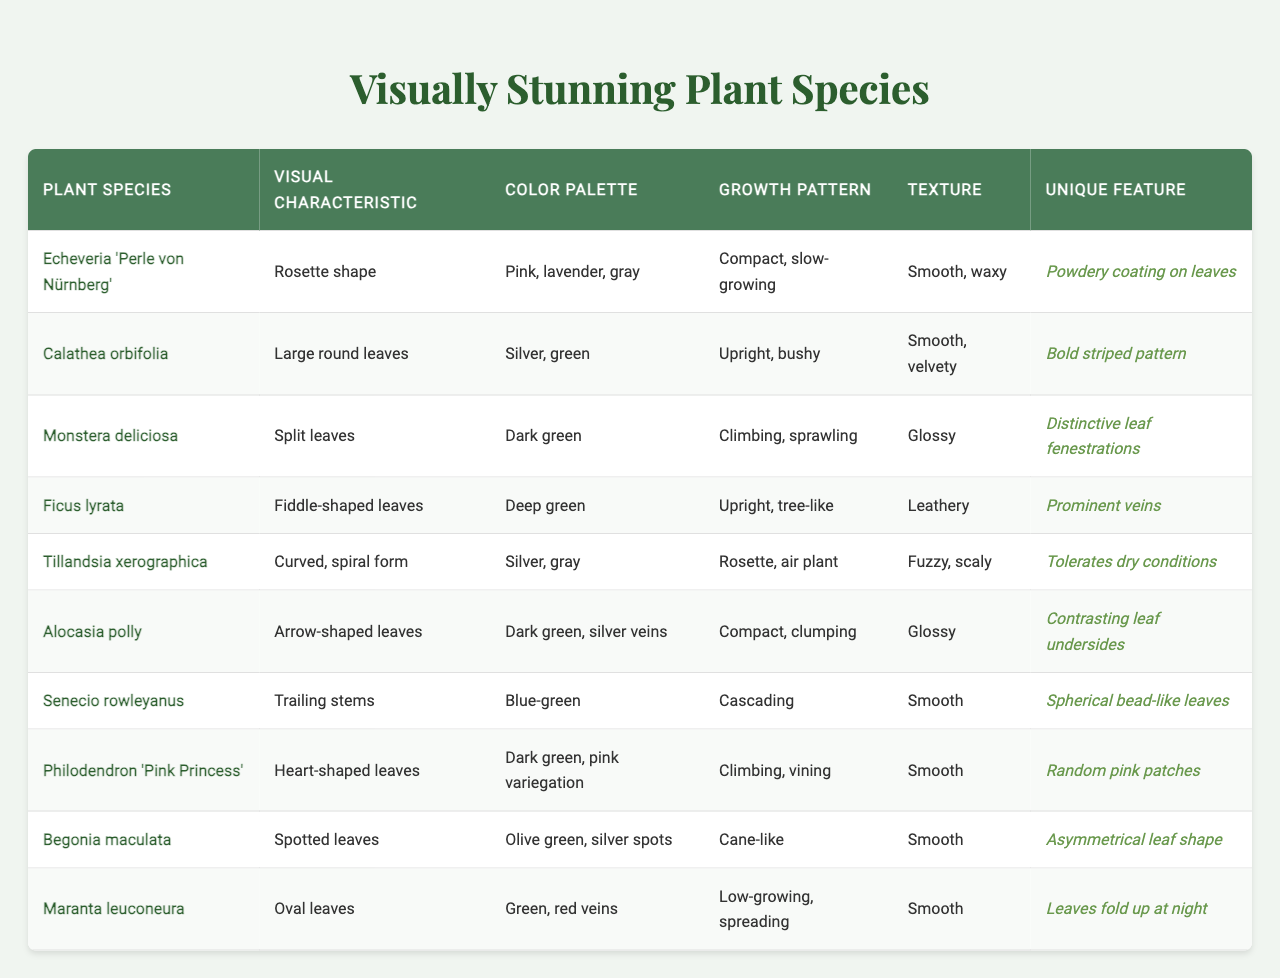What is the visual characteristic of Echeveria 'Perle von Nürnberg'? The table shows that the visual characteristic of Echeveria 'Perle von Nürnberg' is a rosette shape.
Answer: Rosette shape Which plant species has a bold striped pattern? According to the table, Calathea orbifolia is noted for having a bold striped pattern.
Answer: Calathea orbifolia What color palette is associated with Ficus lyrata? The table indicates that the color palette for Ficus lyrata includes deep green.
Answer: Deep green Is Monstera deliciosa known for having smooth leaf texture? The table lists that the texture of Monstera deliciosa is glossy, not smooth, so the answer is no.
Answer: No Which plant has a unique feature of spherical bead-like leaves? The unique feature of Senecio rowleyanus is spherical bead-like leaves, as per the table.
Answer: Senecio rowleyanus What is the growth pattern of Tillandsia xerographica? The table states that Tillandsia xerographica has a rosette growth pattern, characterized as an air plant.
Answer: Rosette, air plant How many plant species in the table have glossy textures? The table lists Monstera deliciosa, Alocasia polly, and Philodendron 'Pink Princess' as having glossy textures. This totals three species.
Answer: Three species Which plant species has both dark green color and pink variegation? The table defines Philodendron 'Pink Princess' as having a dark green color palette with pink variegation.
Answer: Philodendron 'Pink Princess' What is the unique feature of Begonia maculata? The table highlights that the unique feature of Begonia maculata is its asymmetrical leaf shape.
Answer: Asymmetrical leaf shape Considering growth patterns, which plant species are compact and clumping? The table shows that Echeveria 'Perle von Nürnberg' and Alocasia polly have a compact and clumping growth pattern.
Answer: Echeveria 'Perle von Nürnberg' and Alocasia polly 